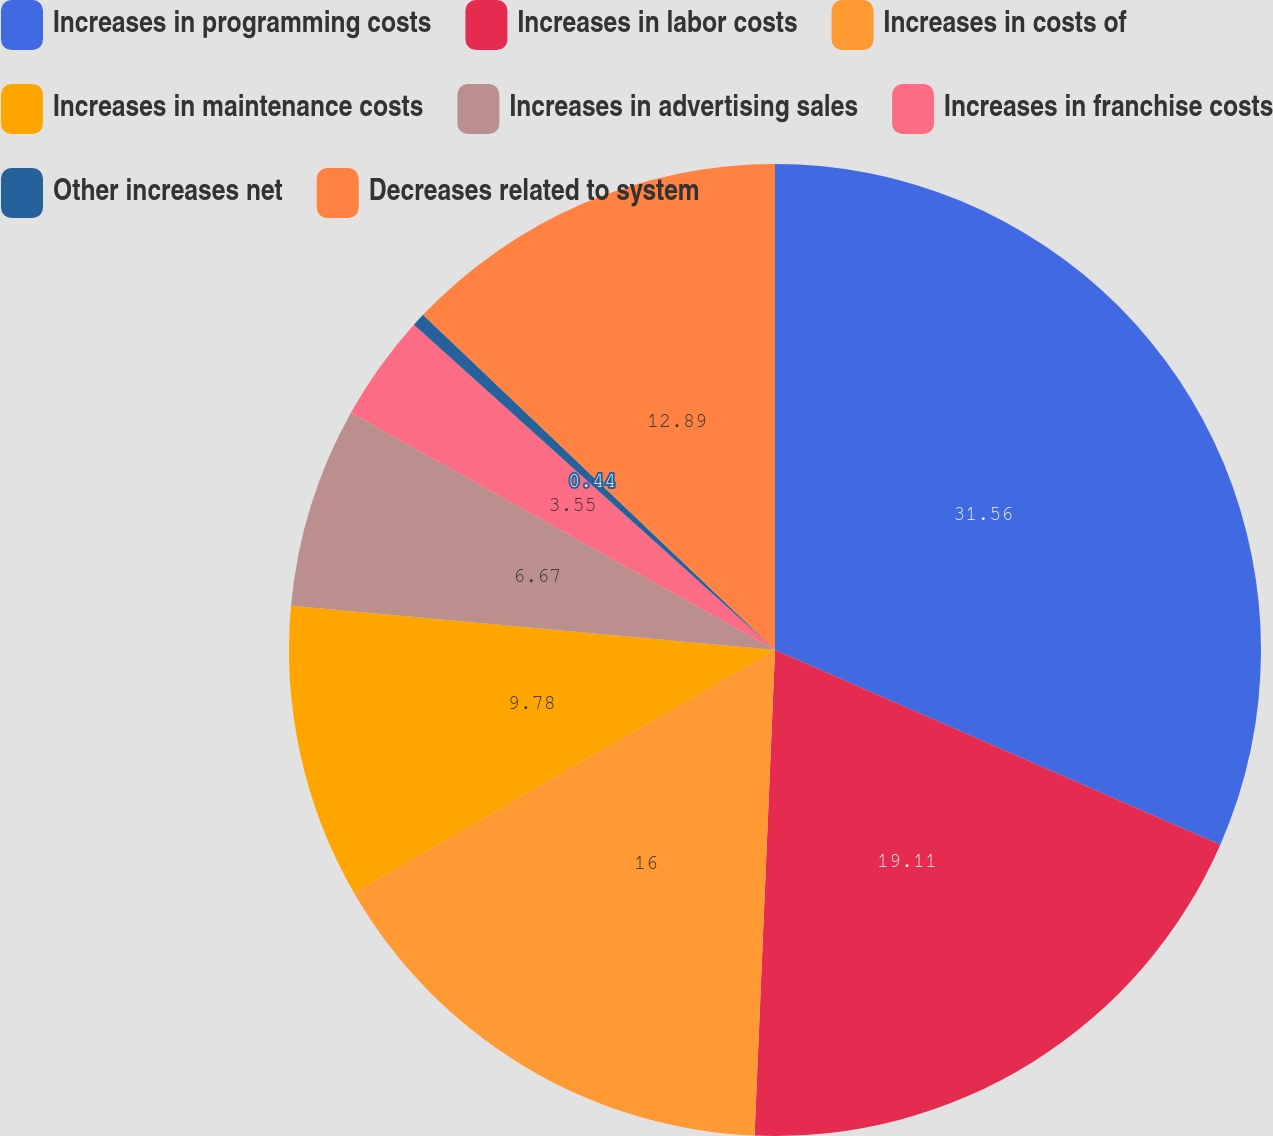<chart> <loc_0><loc_0><loc_500><loc_500><pie_chart><fcel>Increases in programming costs<fcel>Increases in labor costs<fcel>Increases in costs of<fcel>Increases in maintenance costs<fcel>Increases in advertising sales<fcel>Increases in franchise costs<fcel>Other increases net<fcel>Decreases related to system<nl><fcel>31.56%<fcel>19.11%<fcel>16.0%<fcel>9.78%<fcel>6.67%<fcel>3.55%<fcel>0.44%<fcel>12.89%<nl></chart> 